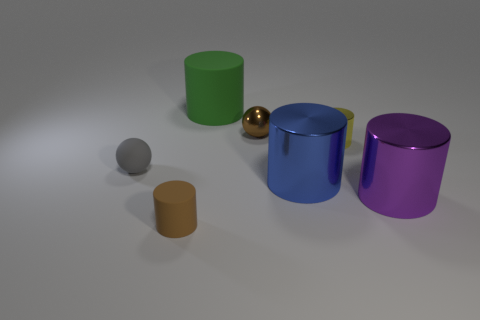Subtract all purple cylinders. How many cylinders are left? 4 Subtract all big purple metallic cylinders. How many cylinders are left? 4 Subtract all red cylinders. Subtract all green spheres. How many cylinders are left? 5 Add 2 large blue metallic cylinders. How many objects exist? 9 Subtract all cylinders. How many objects are left? 2 Subtract all small brown objects. Subtract all brown rubber cylinders. How many objects are left? 4 Add 1 small yellow shiny objects. How many small yellow shiny objects are left? 2 Add 1 big purple metal cylinders. How many big purple metal cylinders exist? 2 Subtract 0 gray blocks. How many objects are left? 7 